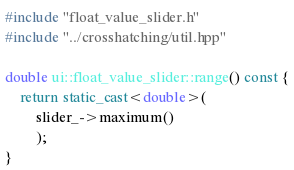<code> <loc_0><loc_0><loc_500><loc_500><_C++_>#include "float_value_slider.h"
#include "../crosshatching/util.hpp"

double ui::float_value_slider::range() const {
	return static_cast<double>(
		slider_->maximum()
		);
}
</code> 